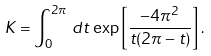<formula> <loc_0><loc_0><loc_500><loc_500>K = \int _ { 0 } ^ { 2 \pi } \, d t \, \exp \left [ \frac { - 4 \pi ^ { 2 } } { t ( 2 \pi - t ) } \right ] .</formula> 